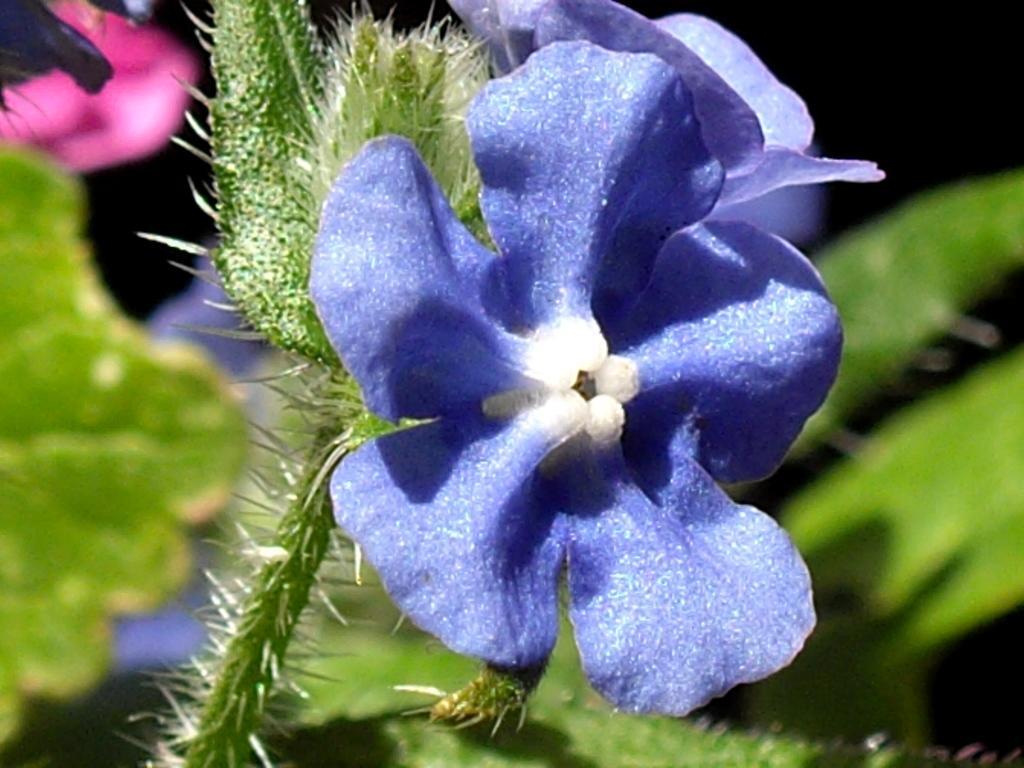Describe this image in one or two sentences. In this image we can see a plant with violet color flower. 